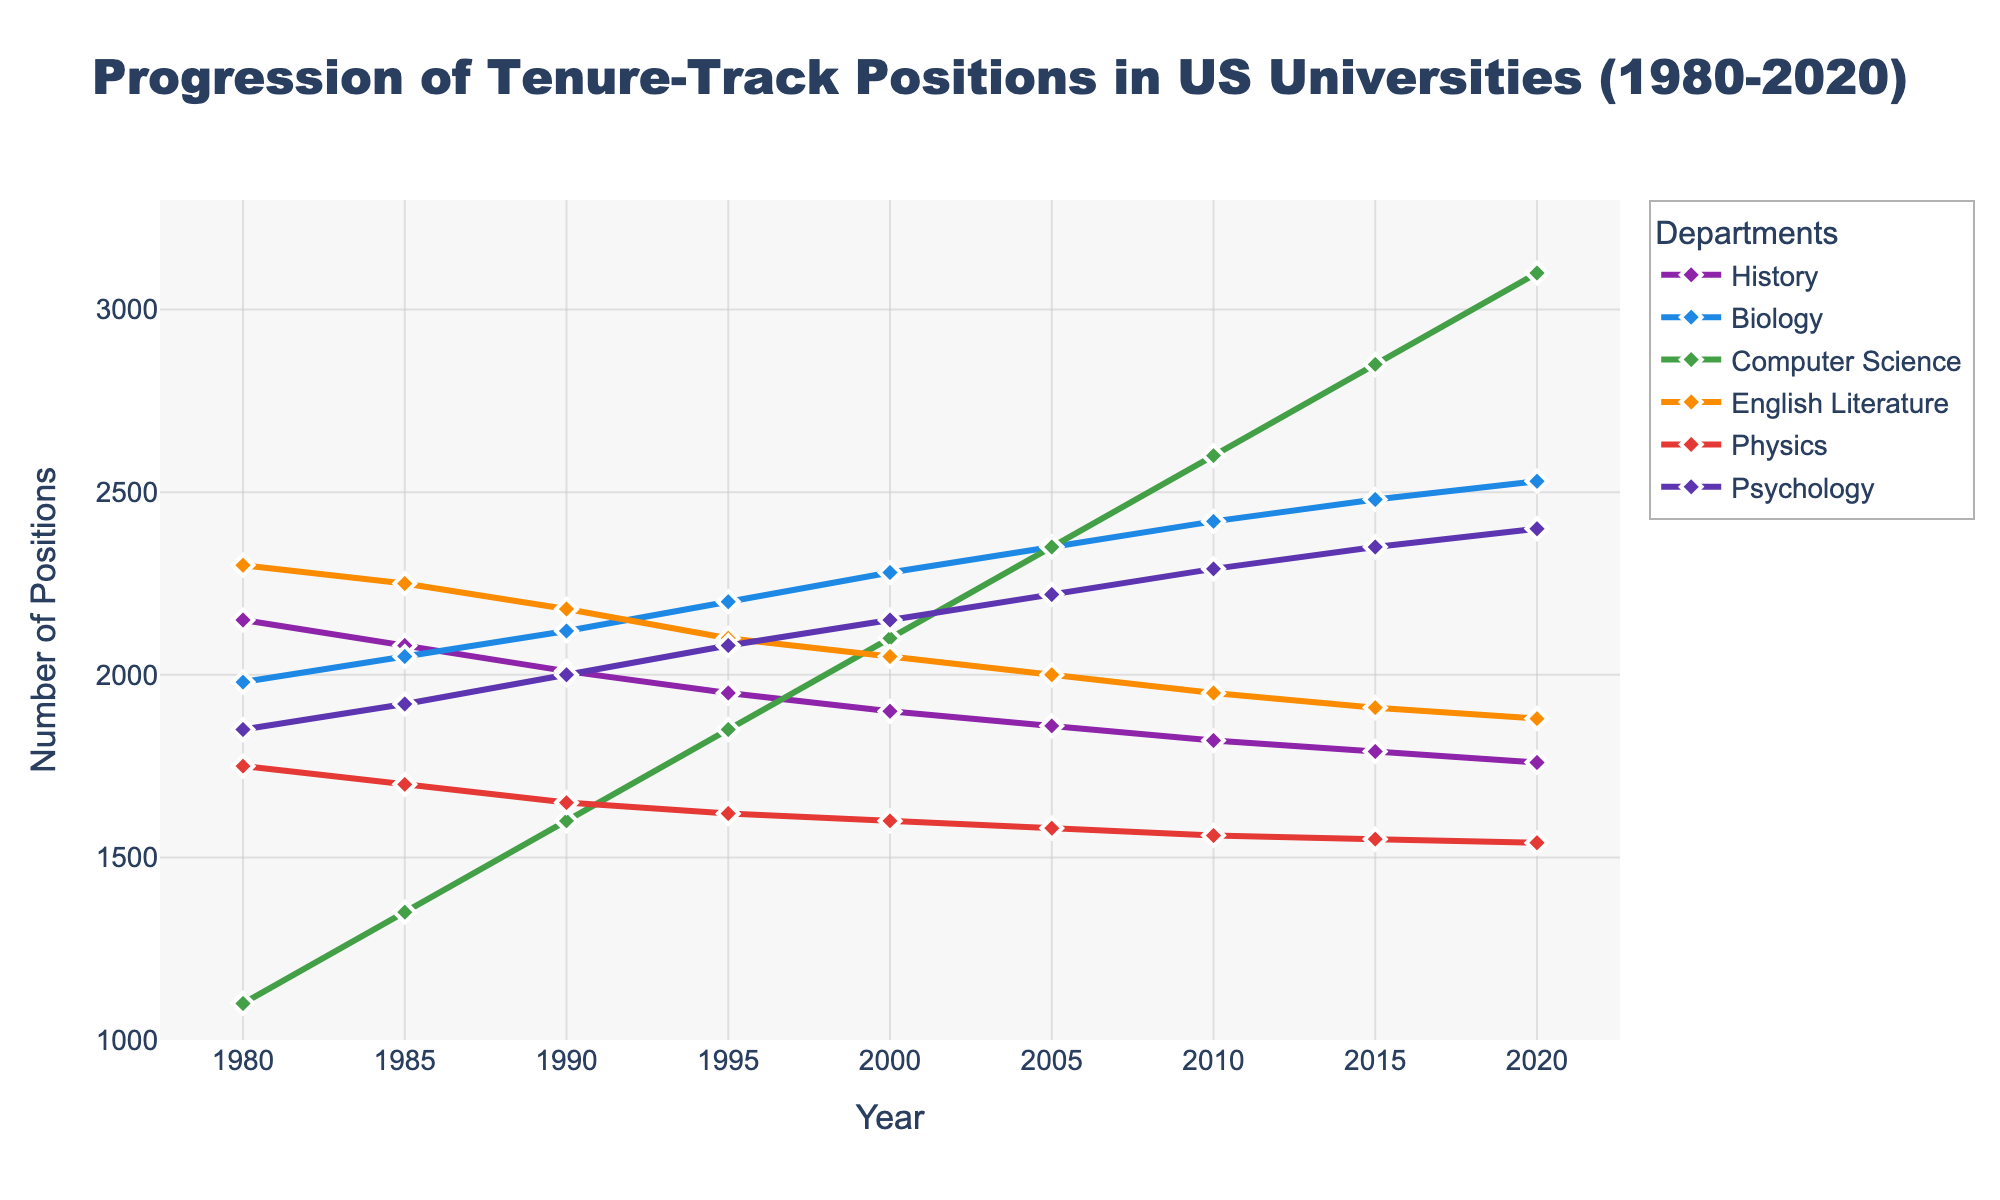What departments have seen a consistent increase in tenure-track positions from 1980 to 2020? To determine if a department has seen a consistent increase, we observe the trend line for each department. The Biology, Computer Science, and Psychology departments show a consistent increase in the number of tenure-track positions over the years.
Answer: Biology, Computer Science, Psychology Which department had the highest number of tenure-track positions in 2020? We look at the y-axis values for the year 2020 and identify which line reaches the highest point. The Computer Science department had the highest number of tenure-track positions in 2020.
Answer: Computer Science By how much did the number of tenure-track positions in Physics change between 1980 and 2020? To find the difference in the number of tenure-track positions in Physics, we subtract the value in 1980 from the value in 2020 (1540 - 1750).
Answer: -210 In what year did the Biology department surpass 2000 tenure-track positions? To determine the year Biology surpassed 2000 tenure-track positions, we look at the trend line for Biology. This occurred in the year 1985.
Answer: 1985 Which department experienced the largest increase in tenure-track positions over the entire period? We calculate the difference in positions from 1980 to 2020 for each department and compare them. Computer Science saw the largest increase, with a difference of (3100 - 1100).
Answer: Computer Science Between 1985 and 1990, which department had the smallest change in tenure-track positions? By calculating the differences in positions for each department between 1985 and 1990 and comparing them, we find that the English Literature department had the smallest change (2250 - 2180).
Answer: English Literature How many departments had fewer tenure-track positions in 2020 compared to their initial values in 1980? We compare the values of each department in 1980 and 2020. Three departments—History, English Literature, and Physics—had fewer tenure-track positions in 2020 compared to 1980.
Answer: Three What is the highest number of tenure-track positions ever recorded across all departments in a single year? To find this, we look at the highest value across all departments and years, which is for Computer Science in 2020 with 3100 positions.
Answer: 3100 Which department had the steepest incline in tenure-track positions between two consecutive data points? To identify this, we check the differences between adjacent years for each department. The largest incline can be observed in the Computer Science department between 2015 and 2020, with a difference of 250 (3100 - 2850).
Answer: Computer Science By what approximate percentage did the number of tenure-track positions in Psychology increase from 1980 to 2020? Percentage increase is calculated as (final value - initial value) / initial value * 100. For Psychology: (2400 - 1850) / 1850 * 100 ≈ 29.73%.
Answer: 29.73% 